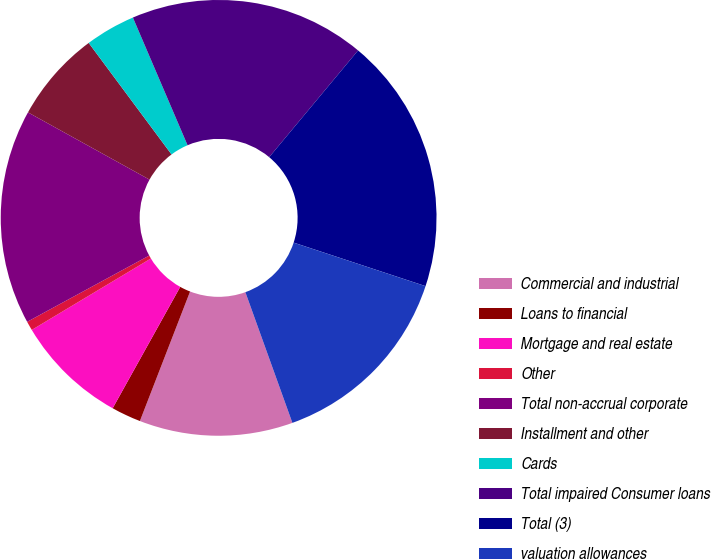Convert chart to OTSL. <chart><loc_0><loc_0><loc_500><loc_500><pie_chart><fcel>Commercial and industrial<fcel>Loans to financial<fcel>Mortgage and real estate<fcel>Other<fcel>Total non-accrual corporate<fcel>Installment and other<fcel>Cards<fcel>Total impaired Consumer loans<fcel>Total (3)<fcel>valuation allowances<nl><fcel>11.38%<fcel>2.2%<fcel>8.32%<fcel>0.68%<fcel>15.96%<fcel>6.79%<fcel>3.73%<fcel>17.49%<fcel>19.02%<fcel>14.43%<nl></chart> 